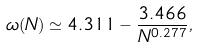<formula> <loc_0><loc_0><loc_500><loc_500>\omega ( N ) \simeq 4 . 3 1 1 - \frac { 3 . 4 6 6 } { N ^ { 0 . 2 7 7 } } ,</formula> 